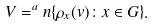<formula> <loc_0><loc_0><loc_500><loc_500>V = ^ { a } n \{ \rho _ { x } ( v ) \colon x \in G \} .</formula> 